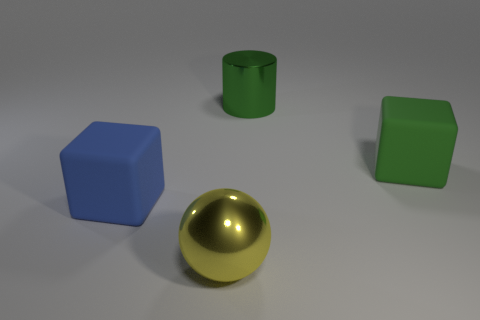Add 2 small cyan cubes. How many objects exist? 6 Subtract all spheres. How many objects are left? 3 Subtract 1 spheres. How many spheres are left? 0 Add 1 tiny cyan metallic balls. How many tiny cyan metallic balls exist? 1 Subtract 1 blue cubes. How many objects are left? 3 Subtract all green spheres. Subtract all yellow cubes. How many spheres are left? 1 Subtract all yellow balls. How many green blocks are left? 1 Subtract all green metallic cylinders. Subtract all big green objects. How many objects are left? 1 Add 2 blue objects. How many blue objects are left? 3 